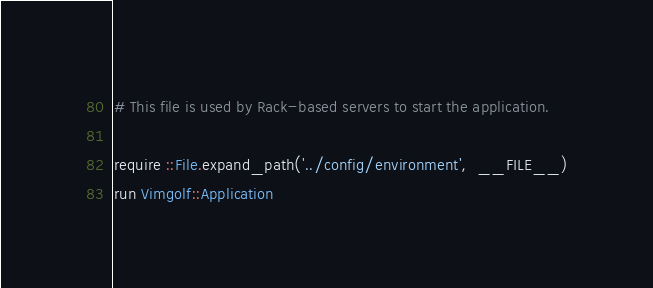<code> <loc_0><loc_0><loc_500><loc_500><_Ruby_># This file is used by Rack-based servers to start the application.

require ::File.expand_path('../config/environment',  __FILE__)
run Vimgolf::Application
</code> 